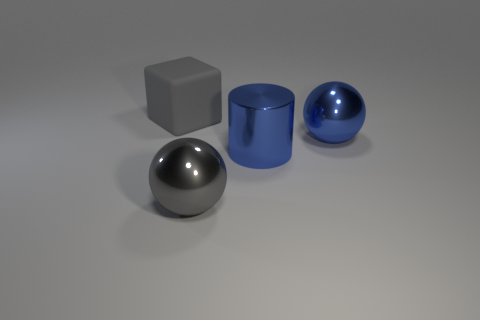Are there the same number of large gray things on the right side of the large blue shiny cylinder and large cyan balls?
Keep it short and to the point. Yes. Is the size of the cube the same as the metallic sphere right of the shiny cylinder?
Your answer should be very brief. Yes. The gray object in front of the big gray cube has what shape?
Your response must be concise. Sphere. Are there any other things that have the same shape as the big gray metallic object?
Provide a succinct answer. Yes. Are any large gray rubber cubes visible?
Keep it short and to the point. Yes. There is a sphere that is behind the big gray metal sphere; is its size the same as the cube left of the large gray sphere?
Your answer should be compact. Yes. What material is the big object that is behind the cylinder and to the right of the big gray block?
Provide a succinct answer. Metal. There is a blue metallic cylinder; how many large blue cylinders are behind it?
Offer a terse response. 0. Is there anything else that has the same size as the blue metallic cylinder?
Offer a terse response. Yes. What color is the cylinder that is the same material as the large gray ball?
Make the answer very short. Blue. 